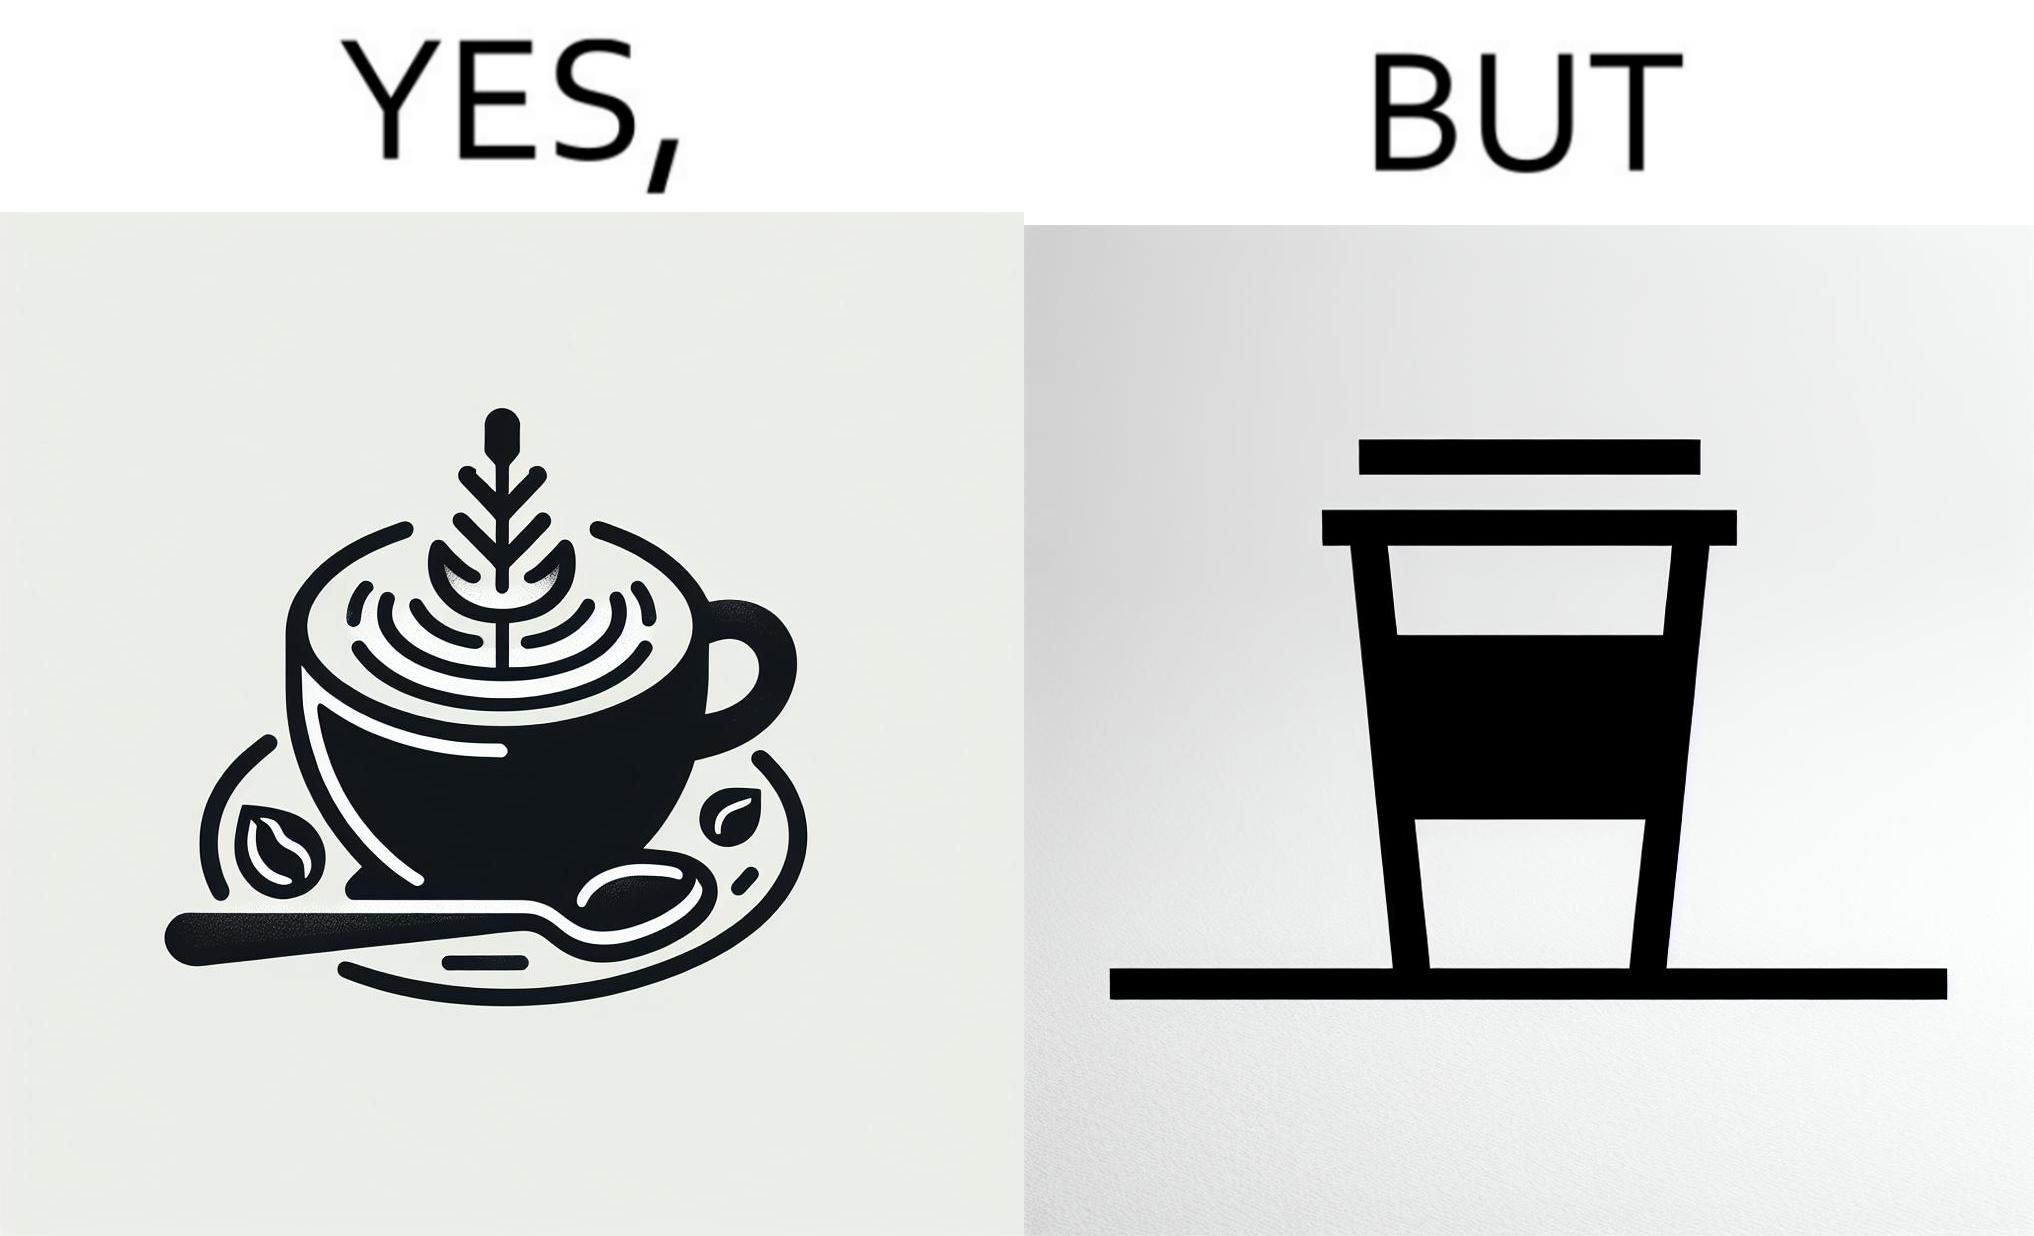What do you see in each half of this image? In the left part of the image: It is a cup of coffee with latte art In the right part of the image: It is a cup of coffee with its lid on top 